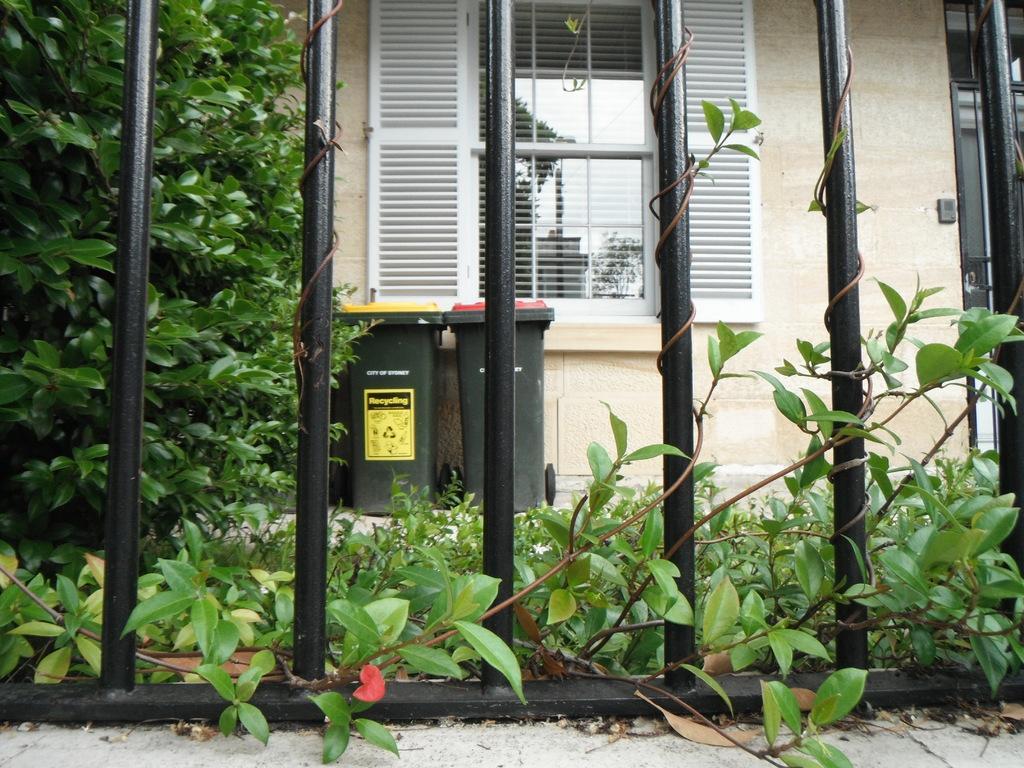Please provide a concise description of this image. In this image we can see dustbins, trees, plants, ground, building and window. 